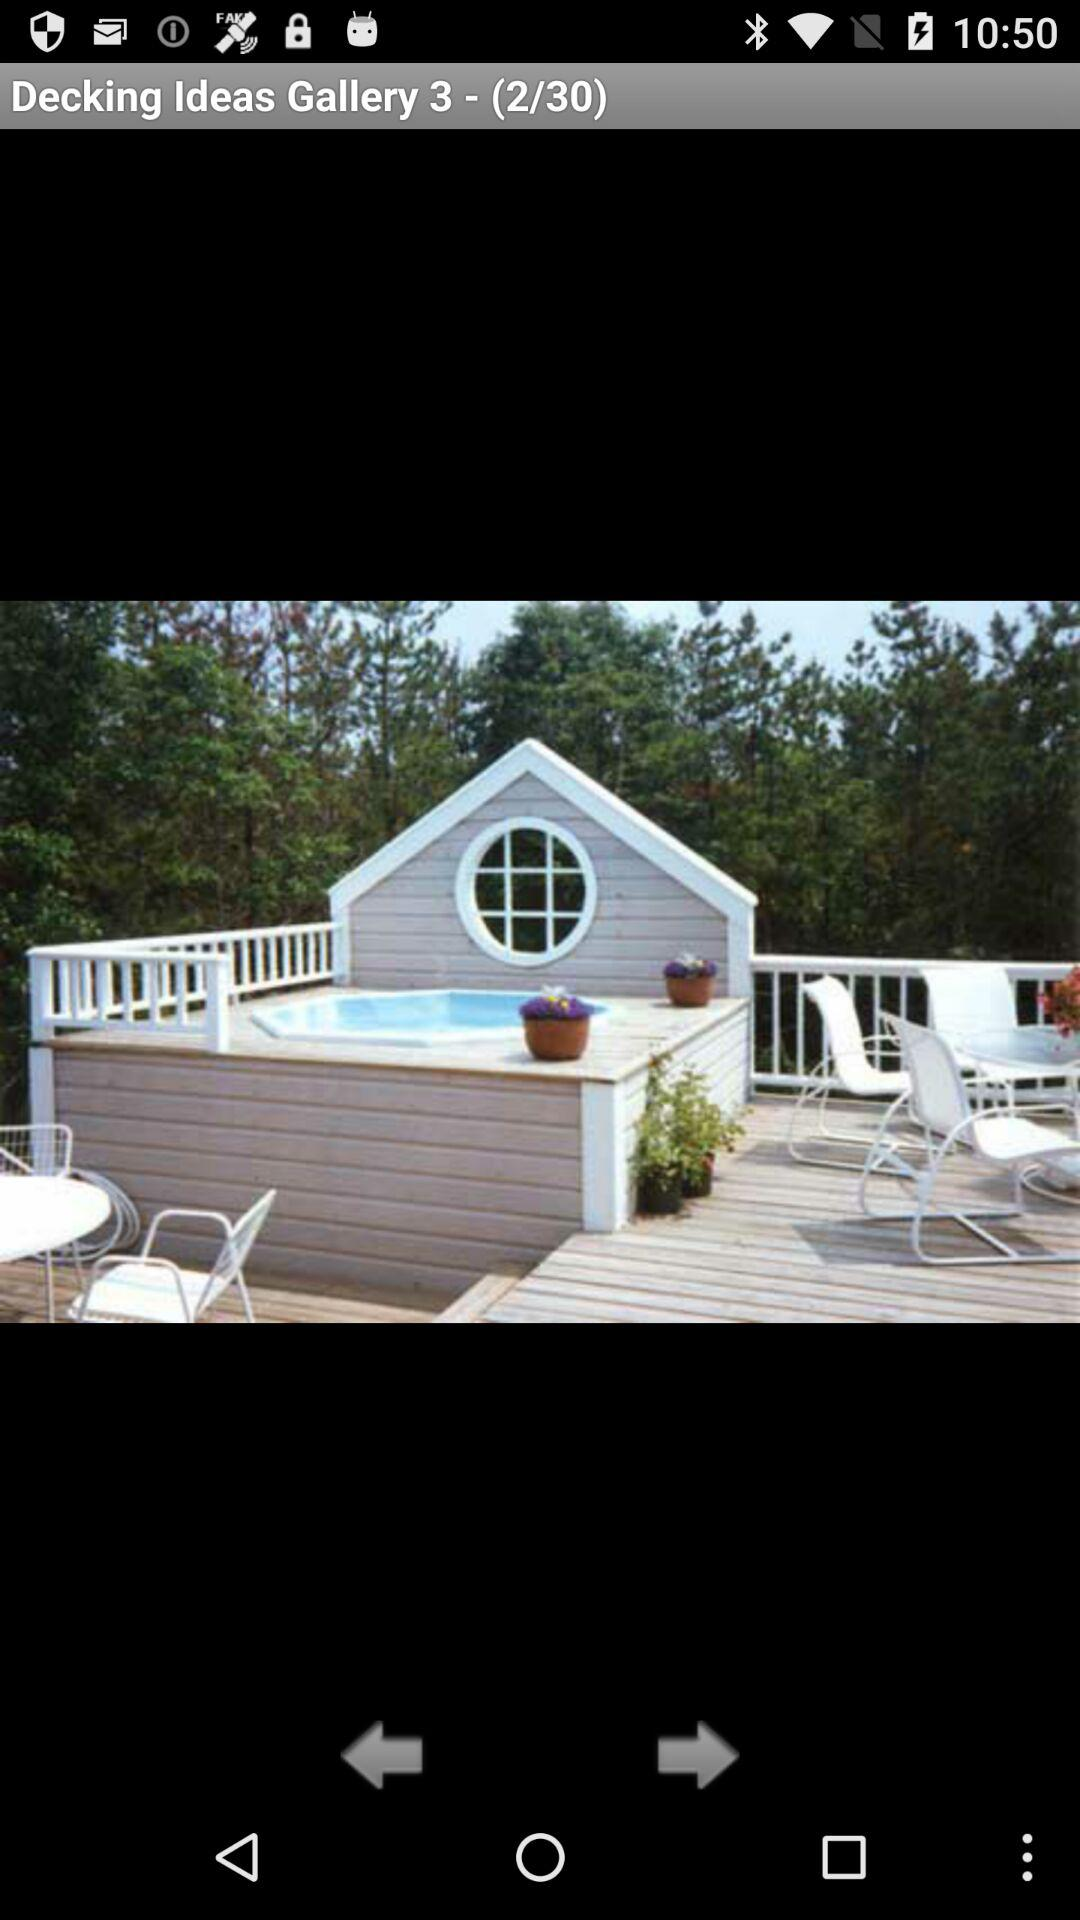What is the name of the gallery?
When the provided information is insufficient, respond with <no answer>. <no answer> 